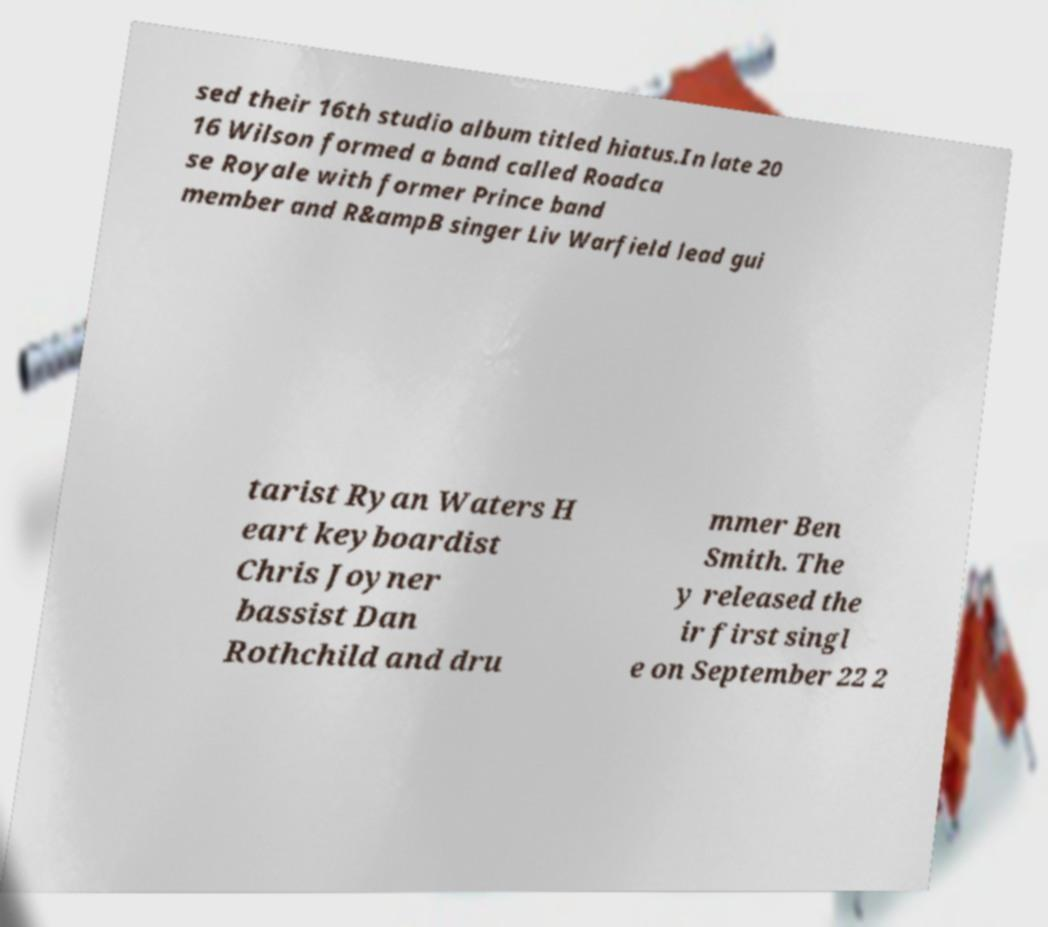I need the written content from this picture converted into text. Can you do that? sed their 16th studio album titled hiatus.In late 20 16 Wilson formed a band called Roadca se Royale with former Prince band member and R&ampB singer Liv Warfield lead gui tarist Ryan Waters H eart keyboardist Chris Joyner bassist Dan Rothchild and dru mmer Ben Smith. The y released the ir first singl e on September 22 2 